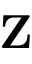<formula> <loc_0><loc_0><loc_500><loc_500>Z</formula> 